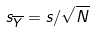<formula> <loc_0><loc_0><loc_500><loc_500>s _ { \overline { Y } } = s / \sqrt { N }</formula> 